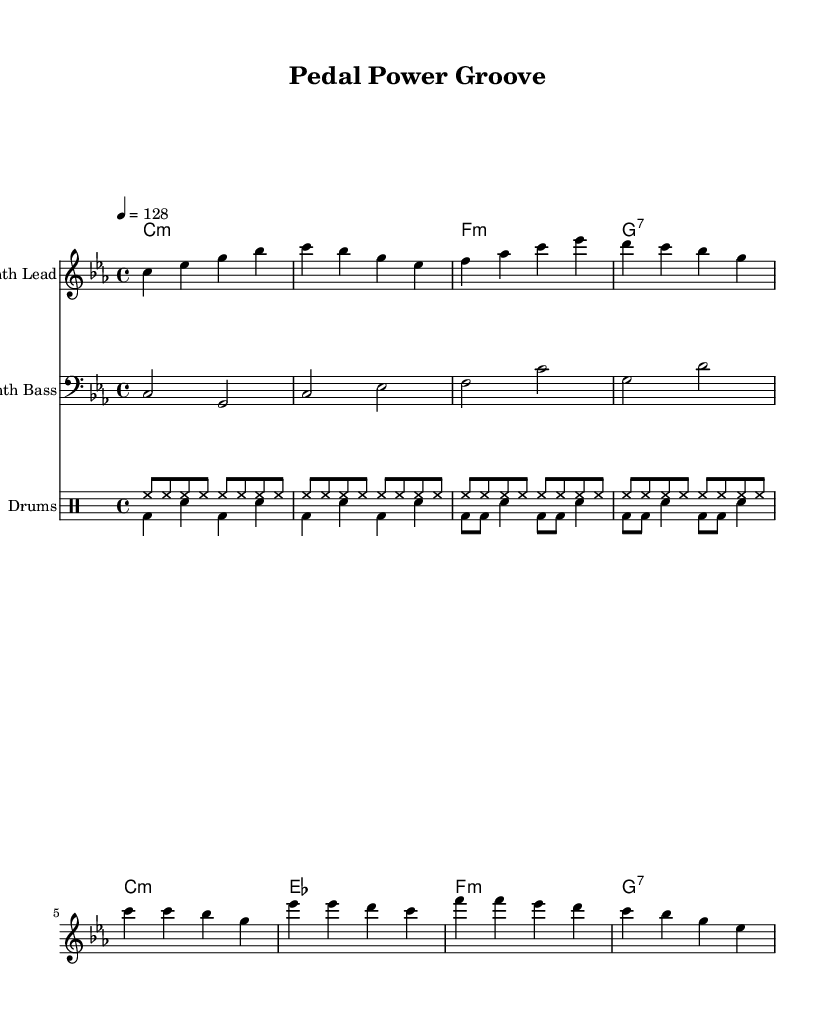What is the key signature of this music? The key signature is C minor, which is indicated by the presence of three flats in the scale (B flat, E flat, and A flat). This can be confirmed by the key signature notation at the beginning of the staff.
Answer: C minor What is the time signature of this piece? The time signature is 4/4, which is indicated at the beginning of the score. This means there are four beats in each measure and the quarter note gets one beat.
Answer: 4/4 What is the tempo marking of the music? The tempo marking is indicated as 4 = 128, telling the performer that there should be 128 beats per minute and each beat corresponds to a quarter note.
Answer: 128 What type of harmony is predominantly used in this piece? The harmony used in the accompaniment is primarily minor, as indicated by the chord symbols such as "m" for minor chords, consistent throughout the verse and chorus sections.
Answer: Minor What rhythmic pattern is used in the drum part? The drum part features a combination of high-hat and bass drum patterns, with a repeating high-hat pattern and alternating bass and snare drum strikes, creating a danceable rhythm suitable for funky house music.
Answer: High-hat and bass drum patterns What is the role of the bass line in this piece? The bass line serves to provide a foundational groove, using a distinct rhythm that complements the harmonic structure and drives the overall dance feel of the piece, which is common in funky house music.
Answer: Groove foundation 